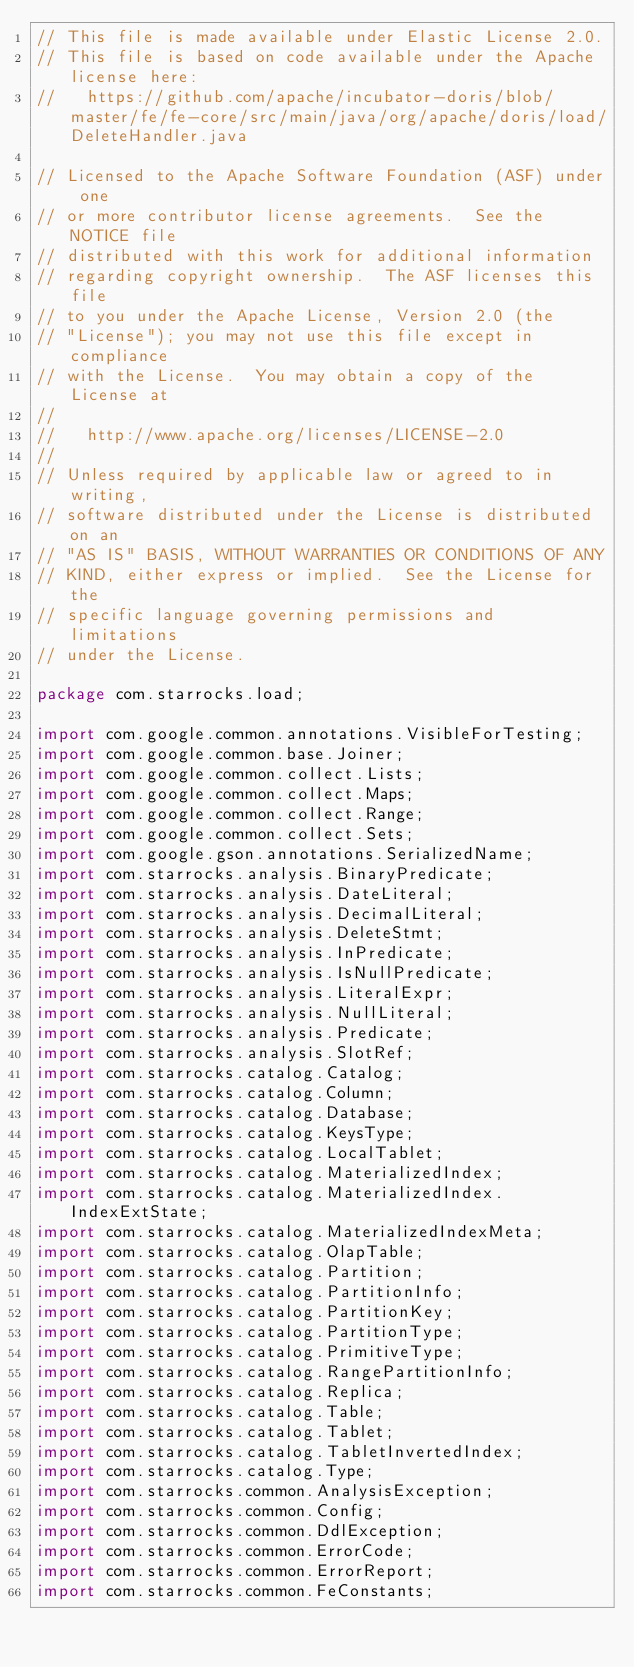Convert code to text. <code><loc_0><loc_0><loc_500><loc_500><_Java_>// This file is made available under Elastic License 2.0.
// This file is based on code available under the Apache license here:
//   https://github.com/apache/incubator-doris/blob/master/fe/fe-core/src/main/java/org/apache/doris/load/DeleteHandler.java

// Licensed to the Apache Software Foundation (ASF) under one
// or more contributor license agreements.  See the NOTICE file
// distributed with this work for additional information
// regarding copyright ownership.  The ASF licenses this file
// to you under the Apache License, Version 2.0 (the
// "License"); you may not use this file except in compliance
// with the License.  You may obtain a copy of the License at
//
//   http://www.apache.org/licenses/LICENSE-2.0
//
// Unless required by applicable law or agreed to in writing,
// software distributed under the License is distributed on an
// "AS IS" BASIS, WITHOUT WARRANTIES OR CONDITIONS OF ANY
// KIND, either express or implied.  See the License for the
// specific language governing permissions and limitations
// under the License.

package com.starrocks.load;

import com.google.common.annotations.VisibleForTesting;
import com.google.common.base.Joiner;
import com.google.common.collect.Lists;
import com.google.common.collect.Maps;
import com.google.common.collect.Range;
import com.google.common.collect.Sets;
import com.google.gson.annotations.SerializedName;
import com.starrocks.analysis.BinaryPredicate;
import com.starrocks.analysis.DateLiteral;
import com.starrocks.analysis.DecimalLiteral;
import com.starrocks.analysis.DeleteStmt;
import com.starrocks.analysis.InPredicate;
import com.starrocks.analysis.IsNullPredicate;
import com.starrocks.analysis.LiteralExpr;
import com.starrocks.analysis.NullLiteral;
import com.starrocks.analysis.Predicate;
import com.starrocks.analysis.SlotRef;
import com.starrocks.catalog.Catalog;
import com.starrocks.catalog.Column;
import com.starrocks.catalog.Database;
import com.starrocks.catalog.KeysType;
import com.starrocks.catalog.LocalTablet;
import com.starrocks.catalog.MaterializedIndex;
import com.starrocks.catalog.MaterializedIndex.IndexExtState;
import com.starrocks.catalog.MaterializedIndexMeta;
import com.starrocks.catalog.OlapTable;
import com.starrocks.catalog.Partition;
import com.starrocks.catalog.PartitionInfo;
import com.starrocks.catalog.PartitionKey;
import com.starrocks.catalog.PartitionType;
import com.starrocks.catalog.PrimitiveType;
import com.starrocks.catalog.RangePartitionInfo;
import com.starrocks.catalog.Replica;
import com.starrocks.catalog.Table;
import com.starrocks.catalog.Tablet;
import com.starrocks.catalog.TabletInvertedIndex;
import com.starrocks.catalog.Type;
import com.starrocks.common.AnalysisException;
import com.starrocks.common.Config;
import com.starrocks.common.DdlException;
import com.starrocks.common.ErrorCode;
import com.starrocks.common.ErrorReport;
import com.starrocks.common.FeConstants;</code> 